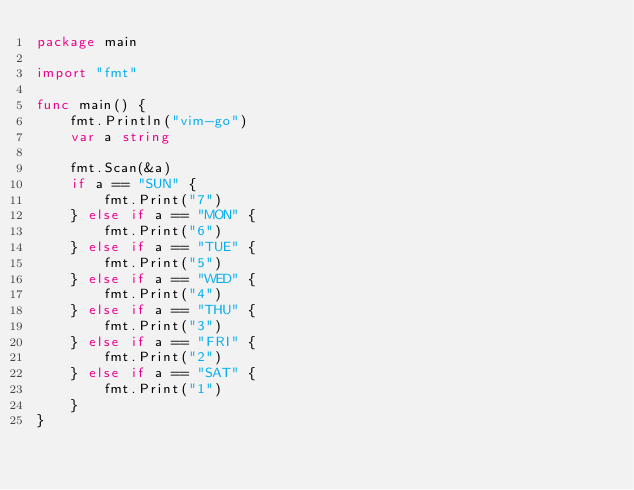<code> <loc_0><loc_0><loc_500><loc_500><_Go_>package main

import "fmt"

func main() {
	fmt.Println("vim-go")
	var a string

	fmt.Scan(&a)
	if a == "SUN" {
		fmt.Print("7")
	} else if a == "MON" {
		fmt.Print("6")
	} else if a == "TUE" {
		fmt.Print("5")
	} else if a == "WED" {
		fmt.Print("4")
	} else if a == "THU" {
		fmt.Print("3")
	} else if a == "FRI" {
		fmt.Print("2")
	} else if a == "SAT" {
		fmt.Print("1")
	}
}
</code> 